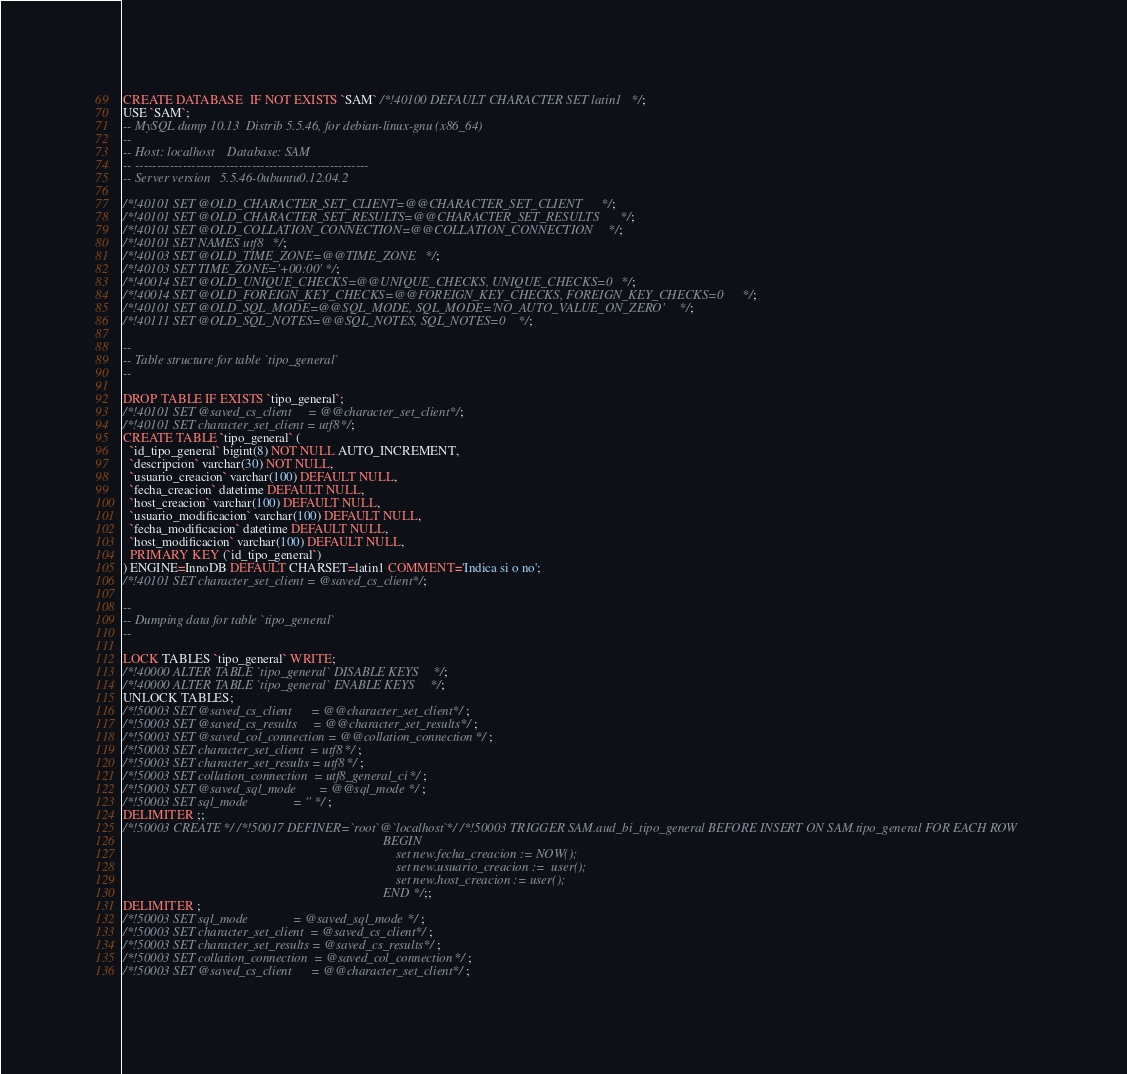Convert code to text. <code><loc_0><loc_0><loc_500><loc_500><_SQL_>CREATE DATABASE  IF NOT EXISTS `SAM` /*!40100 DEFAULT CHARACTER SET latin1 */;
USE `SAM`;
-- MySQL dump 10.13  Distrib 5.5.46, for debian-linux-gnu (x86_64)
--
-- Host: localhost    Database: SAM
-- ------------------------------------------------------
-- Server version	5.5.46-0ubuntu0.12.04.2

/*!40101 SET @OLD_CHARACTER_SET_CLIENT=@@CHARACTER_SET_CLIENT */;
/*!40101 SET @OLD_CHARACTER_SET_RESULTS=@@CHARACTER_SET_RESULTS */;
/*!40101 SET @OLD_COLLATION_CONNECTION=@@COLLATION_CONNECTION */;
/*!40101 SET NAMES utf8 */;
/*!40103 SET @OLD_TIME_ZONE=@@TIME_ZONE */;
/*!40103 SET TIME_ZONE='+00:00' */;
/*!40014 SET @OLD_UNIQUE_CHECKS=@@UNIQUE_CHECKS, UNIQUE_CHECKS=0 */;
/*!40014 SET @OLD_FOREIGN_KEY_CHECKS=@@FOREIGN_KEY_CHECKS, FOREIGN_KEY_CHECKS=0 */;
/*!40101 SET @OLD_SQL_MODE=@@SQL_MODE, SQL_MODE='NO_AUTO_VALUE_ON_ZERO' */;
/*!40111 SET @OLD_SQL_NOTES=@@SQL_NOTES, SQL_NOTES=0 */;

--
-- Table structure for table `tipo_general`
--

DROP TABLE IF EXISTS `tipo_general`;
/*!40101 SET @saved_cs_client     = @@character_set_client */;
/*!40101 SET character_set_client = utf8 */;
CREATE TABLE `tipo_general` (
  `id_tipo_general` bigint(8) NOT NULL AUTO_INCREMENT,
  `descripcion` varchar(30) NOT NULL,
  `usuario_creacion` varchar(100) DEFAULT NULL,
  `fecha_creacion` datetime DEFAULT NULL,
  `host_creacion` varchar(100) DEFAULT NULL,
  `usuario_modificacion` varchar(100) DEFAULT NULL,
  `fecha_modificacion` datetime DEFAULT NULL,
  `host_modificacion` varchar(100) DEFAULT NULL,
  PRIMARY KEY (`id_tipo_general`)
) ENGINE=InnoDB DEFAULT CHARSET=latin1 COMMENT='Indica si o no';
/*!40101 SET character_set_client = @saved_cs_client */;

--
-- Dumping data for table `tipo_general`
--

LOCK TABLES `tipo_general` WRITE;
/*!40000 ALTER TABLE `tipo_general` DISABLE KEYS */;
/*!40000 ALTER TABLE `tipo_general` ENABLE KEYS */;
UNLOCK TABLES;
/*!50003 SET @saved_cs_client      = @@character_set_client */ ;
/*!50003 SET @saved_cs_results     = @@character_set_results */ ;
/*!50003 SET @saved_col_connection = @@collation_connection */ ;
/*!50003 SET character_set_client  = utf8 */ ;
/*!50003 SET character_set_results = utf8 */ ;
/*!50003 SET collation_connection  = utf8_general_ci */ ;
/*!50003 SET @saved_sql_mode       = @@sql_mode */ ;
/*!50003 SET sql_mode              = '' */ ;
DELIMITER ;;
/*!50003 CREATE*/ /*!50017 DEFINER=`root`@`localhost`*/ /*!50003 TRIGGER SAM.aud_bi_tipo_general BEFORE INSERT ON SAM.tipo_general FOR EACH ROW 
                                                                                BEGIN 
                                                                                	set new.fecha_creacion := NOW(); 
                                                                                	set new.usuario_creacion :=  user(); 
                                                                                	set new.host_creacion := user(); 
                                                                                END */;;
DELIMITER ;
/*!50003 SET sql_mode              = @saved_sql_mode */ ;
/*!50003 SET character_set_client  = @saved_cs_client */ ;
/*!50003 SET character_set_results = @saved_cs_results */ ;
/*!50003 SET collation_connection  = @saved_col_connection */ ;
/*!50003 SET @saved_cs_client      = @@character_set_client */ ;</code> 